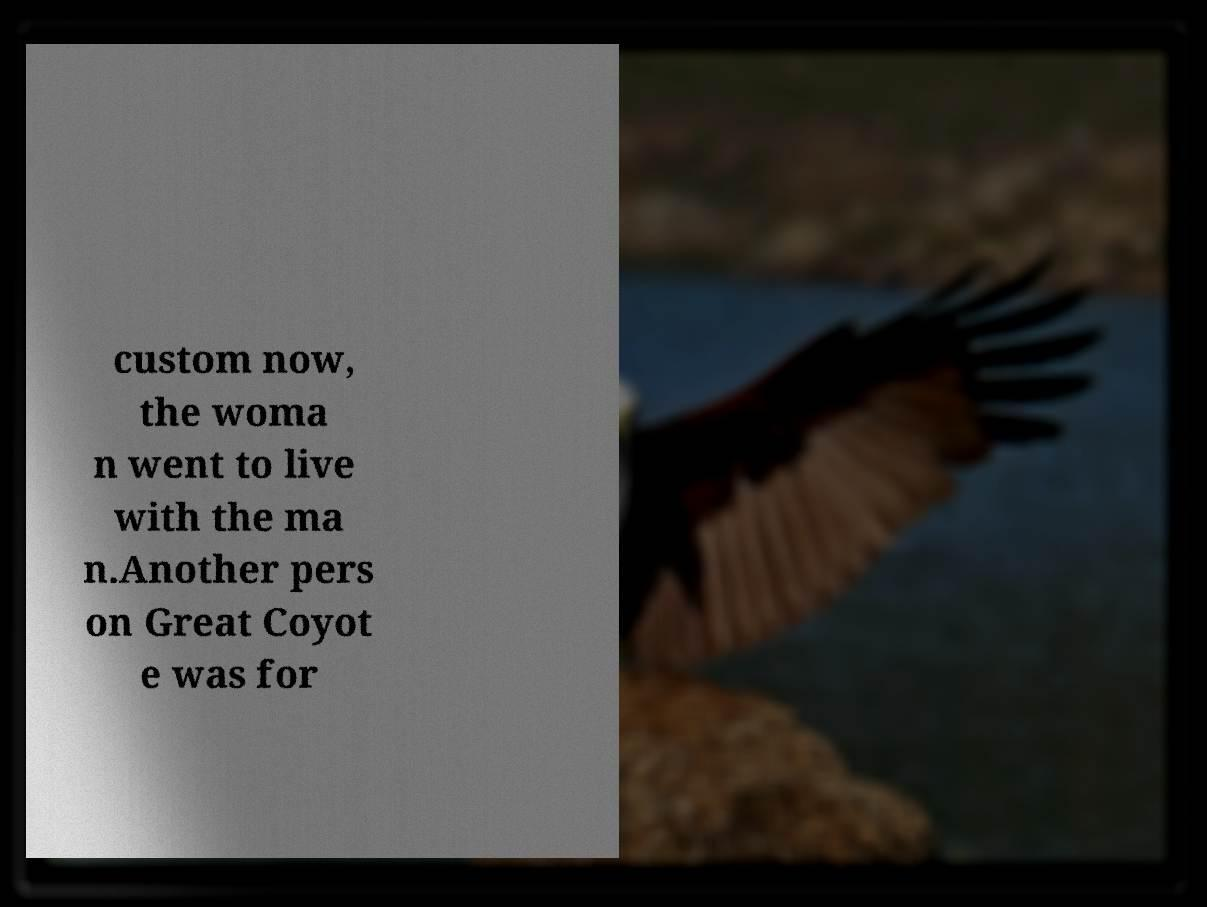I need the written content from this picture converted into text. Can you do that? custom now, the woma n went to live with the ma n.Another pers on Great Coyot e was for 